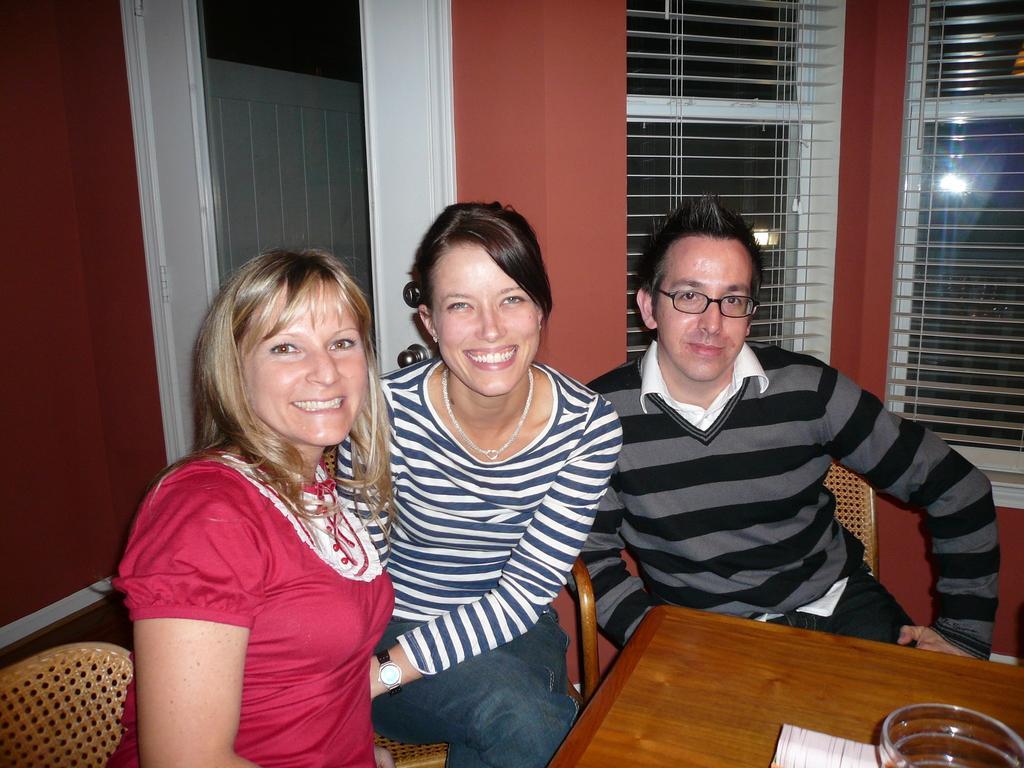Describe this image in one or two sentences. There are three persons sitting and smiling. On the right end a man is wearing specs. In the front there is a table. On the table there is a glass. In the background there are windows, door and a red color wall. 